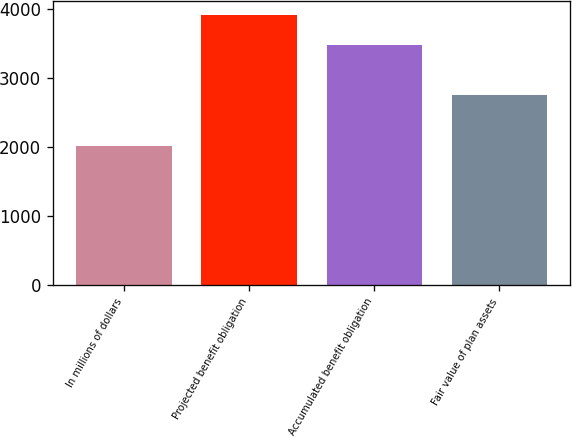Convert chart. <chart><loc_0><loc_0><loc_500><loc_500><bar_chart><fcel>In millions of dollars<fcel>Projected benefit obligation<fcel>Accumulated benefit obligation<fcel>Fair value of plan assets<nl><fcel>2015<fcel>3918<fcel>3488<fcel>2762<nl></chart> 